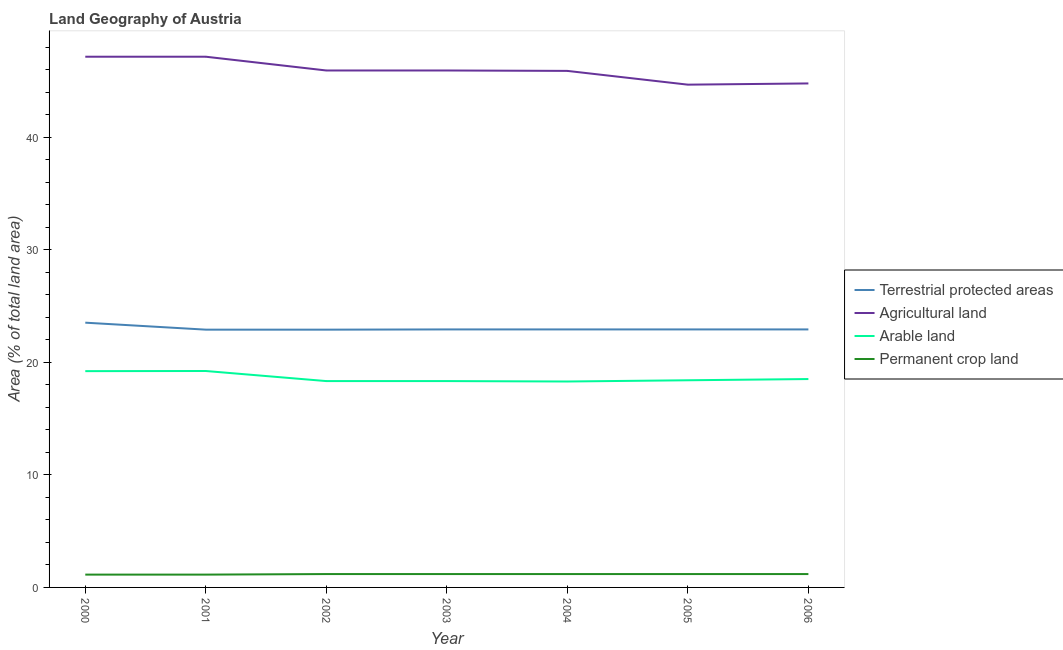Does the line corresponding to percentage of area under arable land intersect with the line corresponding to percentage of land under terrestrial protection?
Offer a very short reply. No. Is the number of lines equal to the number of legend labels?
Your answer should be very brief. Yes. What is the percentage of area under agricultural land in 2001?
Your answer should be very brief. 47.15. Across all years, what is the maximum percentage of area under agricultural land?
Your answer should be compact. 47.15. Across all years, what is the minimum percentage of area under permanent crop land?
Your answer should be very brief. 1.14. In which year was the percentage of area under arable land minimum?
Your response must be concise. 2004. What is the total percentage of area under arable land in the graph?
Keep it short and to the point. 130.33. What is the difference between the percentage of land under terrestrial protection in 2001 and that in 2002?
Your answer should be very brief. -3.987190128995621e-5. What is the difference between the percentage of area under agricultural land in 2006 and the percentage of land under terrestrial protection in 2003?
Ensure brevity in your answer.  21.86. What is the average percentage of area under permanent crop land per year?
Offer a terse response. 1.17. In the year 2002, what is the difference between the percentage of area under agricultural land and percentage of land under terrestrial protection?
Offer a terse response. 23.03. In how many years, is the percentage of land under terrestrial protection greater than 46 %?
Ensure brevity in your answer.  0. What is the ratio of the percentage of area under agricultural land in 2003 to that in 2004?
Ensure brevity in your answer.  1. Is the percentage of area under permanent crop land in 2005 less than that in 2006?
Offer a very short reply. No. What is the difference between the highest and the second highest percentage of area under agricultural land?
Your answer should be very brief. 0. What is the difference between the highest and the lowest percentage of land under terrestrial protection?
Offer a terse response. 0.62. Is the sum of the percentage of area under permanent crop land in 2001 and 2006 greater than the maximum percentage of land under terrestrial protection across all years?
Offer a terse response. No. Is it the case that in every year, the sum of the percentage of area under permanent crop land and percentage of area under arable land is greater than the sum of percentage of land under terrestrial protection and percentage of area under agricultural land?
Your answer should be compact. No. Is it the case that in every year, the sum of the percentage of land under terrestrial protection and percentage of area under agricultural land is greater than the percentage of area under arable land?
Make the answer very short. Yes. Does the percentage of area under permanent crop land monotonically increase over the years?
Your response must be concise. No. Is the percentage of area under permanent crop land strictly greater than the percentage of area under arable land over the years?
Ensure brevity in your answer.  No. Is the percentage of area under permanent crop land strictly less than the percentage of land under terrestrial protection over the years?
Make the answer very short. Yes. Does the graph contain any zero values?
Your answer should be compact. No. Does the graph contain grids?
Give a very brief answer. No. How are the legend labels stacked?
Provide a short and direct response. Vertical. What is the title of the graph?
Your answer should be compact. Land Geography of Austria. Does "Business regulatory environment" appear as one of the legend labels in the graph?
Your response must be concise. No. What is the label or title of the Y-axis?
Your answer should be compact. Area (% of total land area). What is the Area (% of total land area) of Terrestrial protected areas in 2000?
Give a very brief answer. 23.52. What is the Area (% of total land area) in Agricultural land in 2000?
Provide a short and direct response. 47.15. What is the Area (% of total land area) in Arable land in 2000?
Ensure brevity in your answer.  19.22. What is the Area (% of total land area) in Permanent crop land in 2000?
Provide a succinct answer. 1.14. What is the Area (% of total land area) in Terrestrial protected areas in 2001?
Provide a short and direct response. 22.9. What is the Area (% of total land area) in Agricultural land in 2001?
Your answer should be very brief. 47.15. What is the Area (% of total land area) in Arable land in 2001?
Your answer should be compact. 19.23. What is the Area (% of total land area) in Permanent crop land in 2001?
Offer a very short reply. 1.14. What is the Area (% of total land area) in Terrestrial protected areas in 2002?
Your response must be concise. 22.9. What is the Area (% of total land area) in Agricultural land in 2002?
Provide a short and direct response. 45.93. What is the Area (% of total land area) in Arable land in 2002?
Your answer should be compact. 18.33. What is the Area (% of total land area) of Permanent crop land in 2002?
Offer a very short reply. 1.19. What is the Area (% of total land area) in Terrestrial protected areas in 2003?
Your answer should be compact. 22.92. What is the Area (% of total land area) in Agricultural land in 2003?
Provide a short and direct response. 45.93. What is the Area (% of total land area) of Arable land in 2003?
Provide a short and direct response. 18.33. What is the Area (% of total land area) in Permanent crop land in 2003?
Your answer should be very brief. 1.19. What is the Area (% of total land area) in Terrestrial protected areas in 2004?
Provide a succinct answer. 22.92. What is the Area (% of total land area) of Agricultural land in 2004?
Make the answer very short. 45.89. What is the Area (% of total land area) in Arable land in 2004?
Your response must be concise. 18.3. What is the Area (% of total land area) of Permanent crop land in 2004?
Your response must be concise. 1.19. What is the Area (% of total land area) in Terrestrial protected areas in 2005?
Ensure brevity in your answer.  22.92. What is the Area (% of total land area) in Agricultural land in 2005?
Give a very brief answer. 44.67. What is the Area (% of total land area) of Arable land in 2005?
Provide a succinct answer. 18.41. What is the Area (% of total land area) of Permanent crop land in 2005?
Your answer should be compact. 1.19. What is the Area (% of total land area) of Terrestrial protected areas in 2006?
Your answer should be compact. 22.92. What is the Area (% of total land area) of Agricultural land in 2006?
Ensure brevity in your answer.  44.78. What is the Area (% of total land area) of Arable land in 2006?
Offer a very short reply. 18.52. What is the Area (% of total land area) of Permanent crop land in 2006?
Keep it short and to the point. 1.19. Across all years, what is the maximum Area (% of total land area) of Terrestrial protected areas?
Your response must be concise. 23.52. Across all years, what is the maximum Area (% of total land area) of Agricultural land?
Give a very brief answer. 47.15. Across all years, what is the maximum Area (% of total land area) in Arable land?
Offer a terse response. 19.23. Across all years, what is the maximum Area (% of total land area) in Permanent crop land?
Make the answer very short. 1.19. Across all years, what is the minimum Area (% of total land area) of Terrestrial protected areas?
Offer a very short reply. 22.9. Across all years, what is the minimum Area (% of total land area) in Agricultural land?
Give a very brief answer. 44.67. Across all years, what is the minimum Area (% of total land area) of Arable land?
Offer a very short reply. 18.3. Across all years, what is the minimum Area (% of total land area) in Permanent crop land?
Offer a terse response. 1.14. What is the total Area (% of total land area) of Terrestrial protected areas in the graph?
Your answer should be compact. 161.03. What is the total Area (% of total land area) in Agricultural land in the graph?
Give a very brief answer. 321.52. What is the total Area (% of total land area) in Arable land in the graph?
Ensure brevity in your answer.  130.33. What is the total Area (% of total land area) in Permanent crop land in the graph?
Your answer should be compact. 8.21. What is the difference between the Area (% of total land area) of Terrestrial protected areas in 2000 and that in 2001?
Make the answer very short. 0.62. What is the difference between the Area (% of total land area) in Arable land in 2000 and that in 2001?
Make the answer very short. -0.01. What is the difference between the Area (% of total land area) in Terrestrial protected areas in 2000 and that in 2002?
Give a very brief answer. 0.62. What is the difference between the Area (% of total land area) in Agricultural land in 2000 and that in 2002?
Your answer should be compact. 1.22. What is the difference between the Area (% of total land area) of Arable land in 2000 and that in 2002?
Your response must be concise. 0.88. What is the difference between the Area (% of total land area) in Permanent crop land in 2000 and that in 2002?
Your answer should be compact. -0.05. What is the difference between the Area (% of total land area) in Terrestrial protected areas in 2000 and that in 2003?
Your answer should be very brief. 0.6. What is the difference between the Area (% of total land area) in Agricultural land in 2000 and that in 2003?
Provide a succinct answer. 1.22. What is the difference between the Area (% of total land area) in Arable land in 2000 and that in 2003?
Your response must be concise. 0.88. What is the difference between the Area (% of total land area) in Permanent crop land in 2000 and that in 2003?
Make the answer very short. -0.05. What is the difference between the Area (% of total land area) in Terrestrial protected areas in 2000 and that in 2004?
Ensure brevity in your answer.  0.6. What is the difference between the Area (% of total land area) in Agricultural land in 2000 and that in 2004?
Your response must be concise. 1.26. What is the difference between the Area (% of total land area) of Arable land in 2000 and that in 2004?
Your answer should be compact. 0.92. What is the difference between the Area (% of total land area) in Permanent crop land in 2000 and that in 2004?
Provide a succinct answer. -0.05. What is the difference between the Area (% of total land area) in Terrestrial protected areas in 2000 and that in 2005?
Offer a very short reply. 0.6. What is the difference between the Area (% of total land area) of Agricultural land in 2000 and that in 2005?
Make the answer very short. 2.48. What is the difference between the Area (% of total land area) in Arable land in 2000 and that in 2005?
Offer a very short reply. 0.81. What is the difference between the Area (% of total land area) in Permanent crop land in 2000 and that in 2005?
Provide a succinct answer. -0.05. What is the difference between the Area (% of total land area) of Terrestrial protected areas in 2000 and that in 2006?
Make the answer very short. 0.6. What is the difference between the Area (% of total land area) of Agricultural land in 2000 and that in 2006?
Provide a succinct answer. 2.37. What is the difference between the Area (% of total land area) in Arable land in 2000 and that in 2006?
Make the answer very short. 0.7. What is the difference between the Area (% of total land area) of Permanent crop land in 2000 and that in 2006?
Give a very brief answer. -0.05. What is the difference between the Area (% of total land area) in Terrestrial protected areas in 2001 and that in 2002?
Provide a short and direct response. -0. What is the difference between the Area (% of total land area) in Agricultural land in 2001 and that in 2002?
Give a very brief answer. 1.22. What is the difference between the Area (% of total land area) in Arable land in 2001 and that in 2002?
Make the answer very short. 0.9. What is the difference between the Area (% of total land area) of Permanent crop land in 2001 and that in 2002?
Your response must be concise. -0.05. What is the difference between the Area (% of total land area) in Terrestrial protected areas in 2001 and that in 2003?
Keep it short and to the point. -0.02. What is the difference between the Area (% of total land area) of Agricultural land in 2001 and that in 2003?
Offer a very short reply. 1.22. What is the difference between the Area (% of total land area) in Arable land in 2001 and that in 2003?
Provide a short and direct response. 0.9. What is the difference between the Area (% of total land area) in Permanent crop land in 2001 and that in 2003?
Make the answer very short. -0.05. What is the difference between the Area (% of total land area) of Terrestrial protected areas in 2001 and that in 2004?
Your response must be concise. -0.02. What is the difference between the Area (% of total land area) in Agricultural land in 2001 and that in 2004?
Provide a succinct answer. 1.26. What is the difference between the Area (% of total land area) of Arable land in 2001 and that in 2004?
Provide a short and direct response. 0.93. What is the difference between the Area (% of total land area) in Permanent crop land in 2001 and that in 2004?
Your answer should be compact. -0.05. What is the difference between the Area (% of total land area) in Terrestrial protected areas in 2001 and that in 2005?
Give a very brief answer. -0.02. What is the difference between the Area (% of total land area) in Agricultural land in 2001 and that in 2005?
Keep it short and to the point. 2.48. What is the difference between the Area (% of total land area) of Arable land in 2001 and that in 2005?
Give a very brief answer. 0.82. What is the difference between the Area (% of total land area) of Permanent crop land in 2001 and that in 2005?
Your answer should be very brief. -0.05. What is the difference between the Area (% of total land area) of Terrestrial protected areas in 2001 and that in 2006?
Your answer should be very brief. -0.02. What is the difference between the Area (% of total land area) in Agricultural land in 2001 and that in 2006?
Provide a short and direct response. 2.37. What is the difference between the Area (% of total land area) in Arable land in 2001 and that in 2006?
Your response must be concise. 0.71. What is the difference between the Area (% of total land area) in Permanent crop land in 2001 and that in 2006?
Provide a short and direct response. -0.05. What is the difference between the Area (% of total land area) of Terrestrial protected areas in 2002 and that in 2003?
Keep it short and to the point. -0.02. What is the difference between the Area (% of total land area) in Permanent crop land in 2002 and that in 2003?
Your answer should be very brief. 0. What is the difference between the Area (% of total land area) in Terrestrial protected areas in 2002 and that in 2004?
Provide a short and direct response. -0.02. What is the difference between the Area (% of total land area) in Agricultural land in 2002 and that in 2004?
Provide a short and direct response. 0.04. What is the difference between the Area (% of total land area) of Arable land in 2002 and that in 2004?
Offer a terse response. 0.04. What is the difference between the Area (% of total land area) of Permanent crop land in 2002 and that in 2004?
Keep it short and to the point. 0. What is the difference between the Area (% of total land area) of Terrestrial protected areas in 2002 and that in 2005?
Provide a succinct answer. -0.02. What is the difference between the Area (% of total land area) of Agricultural land in 2002 and that in 2005?
Ensure brevity in your answer.  1.26. What is the difference between the Area (% of total land area) in Arable land in 2002 and that in 2005?
Make the answer very short. -0.07. What is the difference between the Area (% of total land area) of Terrestrial protected areas in 2002 and that in 2006?
Offer a very short reply. -0.02. What is the difference between the Area (% of total land area) of Agricultural land in 2002 and that in 2006?
Ensure brevity in your answer.  1.15. What is the difference between the Area (% of total land area) of Arable land in 2002 and that in 2006?
Your answer should be compact. -0.18. What is the difference between the Area (% of total land area) in Permanent crop land in 2002 and that in 2006?
Make the answer very short. 0. What is the difference between the Area (% of total land area) of Terrestrial protected areas in 2003 and that in 2004?
Make the answer very short. 0. What is the difference between the Area (% of total land area) in Agricultural land in 2003 and that in 2004?
Your response must be concise. 0.04. What is the difference between the Area (% of total land area) in Arable land in 2003 and that in 2004?
Give a very brief answer. 0.04. What is the difference between the Area (% of total land area) of Agricultural land in 2003 and that in 2005?
Your response must be concise. 1.26. What is the difference between the Area (% of total land area) in Arable land in 2003 and that in 2005?
Give a very brief answer. -0.07. What is the difference between the Area (% of total land area) in Terrestrial protected areas in 2003 and that in 2006?
Keep it short and to the point. 0. What is the difference between the Area (% of total land area) of Agricultural land in 2003 and that in 2006?
Ensure brevity in your answer.  1.15. What is the difference between the Area (% of total land area) in Arable land in 2003 and that in 2006?
Your answer should be very brief. -0.18. What is the difference between the Area (% of total land area) in Permanent crop land in 2003 and that in 2006?
Your response must be concise. 0. What is the difference between the Area (% of total land area) in Agricultural land in 2004 and that in 2005?
Keep it short and to the point. 1.22. What is the difference between the Area (% of total land area) of Arable land in 2004 and that in 2005?
Offer a very short reply. -0.11. What is the difference between the Area (% of total land area) in Agricultural land in 2004 and that in 2006?
Your answer should be compact. 1.11. What is the difference between the Area (% of total land area) of Arable land in 2004 and that in 2006?
Offer a terse response. -0.22. What is the difference between the Area (% of total land area) in Permanent crop land in 2004 and that in 2006?
Give a very brief answer. 0. What is the difference between the Area (% of total land area) of Terrestrial protected areas in 2005 and that in 2006?
Your answer should be very brief. 0. What is the difference between the Area (% of total land area) in Agricultural land in 2005 and that in 2006?
Keep it short and to the point. -0.11. What is the difference between the Area (% of total land area) of Arable land in 2005 and that in 2006?
Provide a short and direct response. -0.11. What is the difference between the Area (% of total land area) in Terrestrial protected areas in 2000 and the Area (% of total land area) in Agricultural land in 2001?
Your answer should be compact. -23.63. What is the difference between the Area (% of total land area) of Terrestrial protected areas in 2000 and the Area (% of total land area) of Arable land in 2001?
Ensure brevity in your answer.  4.29. What is the difference between the Area (% of total land area) in Terrestrial protected areas in 2000 and the Area (% of total land area) in Permanent crop land in 2001?
Provide a short and direct response. 22.39. What is the difference between the Area (% of total land area) in Agricultural land in 2000 and the Area (% of total land area) in Arable land in 2001?
Give a very brief answer. 27.92. What is the difference between the Area (% of total land area) in Agricultural land in 2000 and the Area (% of total land area) in Permanent crop land in 2001?
Offer a terse response. 46.02. What is the difference between the Area (% of total land area) of Arable land in 2000 and the Area (% of total land area) of Permanent crop land in 2001?
Ensure brevity in your answer.  18.08. What is the difference between the Area (% of total land area) of Terrestrial protected areas in 2000 and the Area (% of total land area) of Agricultural land in 2002?
Keep it short and to the point. -22.41. What is the difference between the Area (% of total land area) of Terrestrial protected areas in 2000 and the Area (% of total land area) of Arable land in 2002?
Make the answer very short. 5.19. What is the difference between the Area (% of total land area) in Terrestrial protected areas in 2000 and the Area (% of total land area) in Permanent crop land in 2002?
Ensure brevity in your answer.  22.34. What is the difference between the Area (% of total land area) of Agricultural land in 2000 and the Area (% of total land area) of Arable land in 2002?
Your answer should be compact. 28.82. What is the difference between the Area (% of total land area) in Agricultural land in 2000 and the Area (% of total land area) in Permanent crop land in 2002?
Offer a very short reply. 45.97. What is the difference between the Area (% of total land area) in Arable land in 2000 and the Area (% of total land area) in Permanent crop land in 2002?
Provide a succinct answer. 18.03. What is the difference between the Area (% of total land area) in Terrestrial protected areas in 2000 and the Area (% of total land area) in Agricultural land in 2003?
Your answer should be compact. -22.41. What is the difference between the Area (% of total land area) of Terrestrial protected areas in 2000 and the Area (% of total land area) of Arable land in 2003?
Your answer should be compact. 5.19. What is the difference between the Area (% of total land area) in Terrestrial protected areas in 2000 and the Area (% of total land area) in Permanent crop land in 2003?
Your response must be concise. 22.34. What is the difference between the Area (% of total land area) in Agricultural land in 2000 and the Area (% of total land area) in Arable land in 2003?
Ensure brevity in your answer.  28.82. What is the difference between the Area (% of total land area) in Agricultural land in 2000 and the Area (% of total land area) in Permanent crop land in 2003?
Provide a short and direct response. 45.97. What is the difference between the Area (% of total land area) in Arable land in 2000 and the Area (% of total land area) in Permanent crop land in 2003?
Give a very brief answer. 18.03. What is the difference between the Area (% of total land area) in Terrestrial protected areas in 2000 and the Area (% of total land area) in Agricultural land in 2004?
Your answer should be very brief. -22.37. What is the difference between the Area (% of total land area) in Terrestrial protected areas in 2000 and the Area (% of total land area) in Arable land in 2004?
Give a very brief answer. 5.23. What is the difference between the Area (% of total land area) in Terrestrial protected areas in 2000 and the Area (% of total land area) in Permanent crop land in 2004?
Offer a terse response. 22.34. What is the difference between the Area (% of total land area) of Agricultural land in 2000 and the Area (% of total land area) of Arable land in 2004?
Provide a succinct answer. 28.86. What is the difference between the Area (% of total land area) in Agricultural land in 2000 and the Area (% of total land area) in Permanent crop land in 2004?
Offer a terse response. 45.97. What is the difference between the Area (% of total land area) of Arable land in 2000 and the Area (% of total land area) of Permanent crop land in 2004?
Keep it short and to the point. 18.03. What is the difference between the Area (% of total land area) of Terrestrial protected areas in 2000 and the Area (% of total land area) of Agricultural land in 2005?
Give a very brief answer. -21.15. What is the difference between the Area (% of total land area) of Terrestrial protected areas in 2000 and the Area (% of total land area) of Arable land in 2005?
Ensure brevity in your answer.  5.12. What is the difference between the Area (% of total land area) of Terrestrial protected areas in 2000 and the Area (% of total land area) of Permanent crop land in 2005?
Offer a terse response. 22.34. What is the difference between the Area (% of total land area) of Agricultural land in 2000 and the Area (% of total land area) of Arable land in 2005?
Ensure brevity in your answer.  28.75. What is the difference between the Area (% of total land area) in Agricultural land in 2000 and the Area (% of total land area) in Permanent crop land in 2005?
Your answer should be compact. 45.97. What is the difference between the Area (% of total land area) in Arable land in 2000 and the Area (% of total land area) in Permanent crop land in 2005?
Provide a succinct answer. 18.03. What is the difference between the Area (% of total land area) in Terrestrial protected areas in 2000 and the Area (% of total land area) in Agricultural land in 2006?
Make the answer very short. -21.26. What is the difference between the Area (% of total land area) of Terrestrial protected areas in 2000 and the Area (% of total land area) of Arable land in 2006?
Offer a very short reply. 5.01. What is the difference between the Area (% of total land area) of Terrestrial protected areas in 2000 and the Area (% of total land area) of Permanent crop land in 2006?
Provide a succinct answer. 22.34. What is the difference between the Area (% of total land area) of Agricultural land in 2000 and the Area (% of total land area) of Arable land in 2006?
Provide a short and direct response. 28.64. What is the difference between the Area (% of total land area) in Agricultural land in 2000 and the Area (% of total land area) in Permanent crop land in 2006?
Give a very brief answer. 45.97. What is the difference between the Area (% of total land area) of Arable land in 2000 and the Area (% of total land area) of Permanent crop land in 2006?
Your response must be concise. 18.03. What is the difference between the Area (% of total land area) of Terrestrial protected areas in 2001 and the Area (% of total land area) of Agricultural land in 2002?
Your answer should be compact. -23.03. What is the difference between the Area (% of total land area) of Terrestrial protected areas in 2001 and the Area (% of total land area) of Arable land in 2002?
Make the answer very short. 4.57. What is the difference between the Area (% of total land area) in Terrestrial protected areas in 2001 and the Area (% of total land area) in Permanent crop land in 2002?
Provide a short and direct response. 21.72. What is the difference between the Area (% of total land area) in Agricultural land in 2001 and the Area (% of total land area) in Arable land in 2002?
Make the answer very short. 28.82. What is the difference between the Area (% of total land area) of Agricultural land in 2001 and the Area (% of total land area) of Permanent crop land in 2002?
Your response must be concise. 45.97. What is the difference between the Area (% of total land area) in Arable land in 2001 and the Area (% of total land area) in Permanent crop land in 2002?
Provide a short and direct response. 18.04. What is the difference between the Area (% of total land area) in Terrestrial protected areas in 2001 and the Area (% of total land area) in Agricultural land in 2003?
Ensure brevity in your answer.  -23.03. What is the difference between the Area (% of total land area) in Terrestrial protected areas in 2001 and the Area (% of total land area) in Arable land in 2003?
Your answer should be very brief. 4.57. What is the difference between the Area (% of total land area) of Terrestrial protected areas in 2001 and the Area (% of total land area) of Permanent crop land in 2003?
Your answer should be very brief. 21.72. What is the difference between the Area (% of total land area) in Agricultural land in 2001 and the Area (% of total land area) in Arable land in 2003?
Give a very brief answer. 28.82. What is the difference between the Area (% of total land area) of Agricultural land in 2001 and the Area (% of total land area) of Permanent crop land in 2003?
Your response must be concise. 45.97. What is the difference between the Area (% of total land area) in Arable land in 2001 and the Area (% of total land area) in Permanent crop land in 2003?
Offer a terse response. 18.04. What is the difference between the Area (% of total land area) in Terrestrial protected areas in 2001 and the Area (% of total land area) in Agricultural land in 2004?
Keep it short and to the point. -22.99. What is the difference between the Area (% of total land area) in Terrestrial protected areas in 2001 and the Area (% of total land area) in Arable land in 2004?
Make the answer very short. 4.61. What is the difference between the Area (% of total land area) in Terrestrial protected areas in 2001 and the Area (% of total land area) in Permanent crop land in 2004?
Provide a succinct answer. 21.72. What is the difference between the Area (% of total land area) of Agricultural land in 2001 and the Area (% of total land area) of Arable land in 2004?
Your answer should be very brief. 28.86. What is the difference between the Area (% of total land area) in Agricultural land in 2001 and the Area (% of total land area) in Permanent crop land in 2004?
Offer a terse response. 45.97. What is the difference between the Area (% of total land area) in Arable land in 2001 and the Area (% of total land area) in Permanent crop land in 2004?
Your answer should be very brief. 18.04. What is the difference between the Area (% of total land area) of Terrestrial protected areas in 2001 and the Area (% of total land area) of Agricultural land in 2005?
Your answer should be compact. -21.77. What is the difference between the Area (% of total land area) of Terrestrial protected areas in 2001 and the Area (% of total land area) of Arable land in 2005?
Offer a terse response. 4.5. What is the difference between the Area (% of total land area) in Terrestrial protected areas in 2001 and the Area (% of total land area) in Permanent crop land in 2005?
Ensure brevity in your answer.  21.72. What is the difference between the Area (% of total land area) of Agricultural land in 2001 and the Area (% of total land area) of Arable land in 2005?
Your answer should be very brief. 28.75. What is the difference between the Area (% of total land area) of Agricultural land in 2001 and the Area (% of total land area) of Permanent crop land in 2005?
Offer a terse response. 45.97. What is the difference between the Area (% of total land area) of Arable land in 2001 and the Area (% of total land area) of Permanent crop land in 2005?
Provide a succinct answer. 18.04. What is the difference between the Area (% of total land area) in Terrestrial protected areas in 2001 and the Area (% of total land area) in Agricultural land in 2006?
Keep it short and to the point. -21.88. What is the difference between the Area (% of total land area) of Terrestrial protected areas in 2001 and the Area (% of total land area) of Arable land in 2006?
Offer a very short reply. 4.39. What is the difference between the Area (% of total land area) of Terrestrial protected areas in 2001 and the Area (% of total land area) of Permanent crop land in 2006?
Make the answer very short. 21.72. What is the difference between the Area (% of total land area) of Agricultural land in 2001 and the Area (% of total land area) of Arable land in 2006?
Ensure brevity in your answer.  28.64. What is the difference between the Area (% of total land area) of Agricultural land in 2001 and the Area (% of total land area) of Permanent crop land in 2006?
Make the answer very short. 45.97. What is the difference between the Area (% of total land area) of Arable land in 2001 and the Area (% of total land area) of Permanent crop land in 2006?
Your answer should be compact. 18.04. What is the difference between the Area (% of total land area) in Terrestrial protected areas in 2002 and the Area (% of total land area) in Agricultural land in 2003?
Keep it short and to the point. -23.03. What is the difference between the Area (% of total land area) in Terrestrial protected areas in 2002 and the Area (% of total land area) in Arable land in 2003?
Keep it short and to the point. 4.57. What is the difference between the Area (% of total land area) in Terrestrial protected areas in 2002 and the Area (% of total land area) in Permanent crop land in 2003?
Provide a succinct answer. 21.72. What is the difference between the Area (% of total land area) of Agricultural land in 2002 and the Area (% of total land area) of Arable land in 2003?
Make the answer very short. 27.6. What is the difference between the Area (% of total land area) of Agricultural land in 2002 and the Area (% of total land area) of Permanent crop land in 2003?
Give a very brief answer. 44.74. What is the difference between the Area (% of total land area) of Arable land in 2002 and the Area (% of total land area) of Permanent crop land in 2003?
Make the answer very short. 17.15. What is the difference between the Area (% of total land area) of Terrestrial protected areas in 2002 and the Area (% of total land area) of Agricultural land in 2004?
Provide a succinct answer. -22.99. What is the difference between the Area (% of total land area) of Terrestrial protected areas in 2002 and the Area (% of total land area) of Arable land in 2004?
Your answer should be very brief. 4.61. What is the difference between the Area (% of total land area) in Terrestrial protected areas in 2002 and the Area (% of total land area) in Permanent crop land in 2004?
Provide a succinct answer. 21.72. What is the difference between the Area (% of total land area) of Agricultural land in 2002 and the Area (% of total land area) of Arable land in 2004?
Your answer should be compact. 27.63. What is the difference between the Area (% of total land area) in Agricultural land in 2002 and the Area (% of total land area) in Permanent crop land in 2004?
Offer a terse response. 44.74. What is the difference between the Area (% of total land area) in Arable land in 2002 and the Area (% of total land area) in Permanent crop land in 2004?
Offer a terse response. 17.15. What is the difference between the Area (% of total land area) in Terrestrial protected areas in 2002 and the Area (% of total land area) in Agricultural land in 2005?
Give a very brief answer. -21.77. What is the difference between the Area (% of total land area) of Terrestrial protected areas in 2002 and the Area (% of total land area) of Arable land in 2005?
Your answer should be compact. 4.5. What is the difference between the Area (% of total land area) in Terrestrial protected areas in 2002 and the Area (% of total land area) in Permanent crop land in 2005?
Offer a terse response. 21.72. What is the difference between the Area (% of total land area) in Agricultural land in 2002 and the Area (% of total land area) in Arable land in 2005?
Offer a terse response. 27.52. What is the difference between the Area (% of total land area) in Agricultural land in 2002 and the Area (% of total land area) in Permanent crop land in 2005?
Your answer should be very brief. 44.74. What is the difference between the Area (% of total land area) of Arable land in 2002 and the Area (% of total land area) of Permanent crop land in 2005?
Your answer should be very brief. 17.15. What is the difference between the Area (% of total land area) in Terrestrial protected areas in 2002 and the Area (% of total land area) in Agricultural land in 2006?
Offer a very short reply. -21.88. What is the difference between the Area (% of total land area) of Terrestrial protected areas in 2002 and the Area (% of total land area) of Arable land in 2006?
Your response must be concise. 4.39. What is the difference between the Area (% of total land area) of Terrestrial protected areas in 2002 and the Area (% of total land area) of Permanent crop land in 2006?
Your answer should be very brief. 21.72. What is the difference between the Area (% of total land area) in Agricultural land in 2002 and the Area (% of total land area) in Arable land in 2006?
Provide a succinct answer. 27.42. What is the difference between the Area (% of total land area) in Agricultural land in 2002 and the Area (% of total land area) in Permanent crop land in 2006?
Your answer should be very brief. 44.74. What is the difference between the Area (% of total land area) in Arable land in 2002 and the Area (% of total land area) in Permanent crop land in 2006?
Ensure brevity in your answer.  17.15. What is the difference between the Area (% of total land area) of Terrestrial protected areas in 2003 and the Area (% of total land area) of Agricultural land in 2004?
Ensure brevity in your answer.  -22.97. What is the difference between the Area (% of total land area) in Terrestrial protected areas in 2003 and the Area (% of total land area) in Arable land in 2004?
Make the answer very short. 4.63. What is the difference between the Area (% of total land area) in Terrestrial protected areas in 2003 and the Area (% of total land area) in Permanent crop land in 2004?
Keep it short and to the point. 21.74. What is the difference between the Area (% of total land area) of Agricultural land in 2003 and the Area (% of total land area) of Arable land in 2004?
Offer a very short reply. 27.63. What is the difference between the Area (% of total land area) in Agricultural land in 2003 and the Area (% of total land area) in Permanent crop land in 2004?
Ensure brevity in your answer.  44.74. What is the difference between the Area (% of total land area) in Arable land in 2003 and the Area (% of total land area) in Permanent crop land in 2004?
Your response must be concise. 17.15. What is the difference between the Area (% of total land area) in Terrestrial protected areas in 2003 and the Area (% of total land area) in Agricultural land in 2005?
Offer a very short reply. -21.75. What is the difference between the Area (% of total land area) of Terrestrial protected areas in 2003 and the Area (% of total land area) of Arable land in 2005?
Offer a terse response. 4.52. What is the difference between the Area (% of total land area) in Terrestrial protected areas in 2003 and the Area (% of total land area) in Permanent crop land in 2005?
Provide a short and direct response. 21.74. What is the difference between the Area (% of total land area) of Agricultural land in 2003 and the Area (% of total land area) of Arable land in 2005?
Offer a terse response. 27.52. What is the difference between the Area (% of total land area) in Agricultural land in 2003 and the Area (% of total land area) in Permanent crop land in 2005?
Offer a terse response. 44.74. What is the difference between the Area (% of total land area) of Arable land in 2003 and the Area (% of total land area) of Permanent crop land in 2005?
Your answer should be very brief. 17.15. What is the difference between the Area (% of total land area) of Terrestrial protected areas in 2003 and the Area (% of total land area) of Agricultural land in 2006?
Offer a terse response. -21.86. What is the difference between the Area (% of total land area) in Terrestrial protected areas in 2003 and the Area (% of total land area) in Arable land in 2006?
Give a very brief answer. 4.41. What is the difference between the Area (% of total land area) of Terrestrial protected areas in 2003 and the Area (% of total land area) of Permanent crop land in 2006?
Keep it short and to the point. 21.74. What is the difference between the Area (% of total land area) of Agricultural land in 2003 and the Area (% of total land area) of Arable land in 2006?
Your answer should be compact. 27.42. What is the difference between the Area (% of total land area) of Agricultural land in 2003 and the Area (% of total land area) of Permanent crop land in 2006?
Your answer should be very brief. 44.74. What is the difference between the Area (% of total land area) of Arable land in 2003 and the Area (% of total land area) of Permanent crop land in 2006?
Make the answer very short. 17.15. What is the difference between the Area (% of total land area) in Terrestrial protected areas in 2004 and the Area (% of total land area) in Agricultural land in 2005?
Give a very brief answer. -21.75. What is the difference between the Area (% of total land area) in Terrestrial protected areas in 2004 and the Area (% of total land area) in Arable land in 2005?
Offer a terse response. 4.52. What is the difference between the Area (% of total land area) of Terrestrial protected areas in 2004 and the Area (% of total land area) of Permanent crop land in 2005?
Your answer should be compact. 21.74. What is the difference between the Area (% of total land area) of Agricultural land in 2004 and the Area (% of total land area) of Arable land in 2005?
Your response must be concise. 27.49. What is the difference between the Area (% of total land area) of Agricultural land in 2004 and the Area (% of total land area) of Permanent crop land in 2005?
Provide a short and direct response. 44.71. What is the difference between the Area (% of total land area) of Arable land in 2004 and the Area (% of total land area) of Permanent crop land in 2005?
Your answer should be very brief. 17.11. What is the difference between the Area (% of total land area) in Terrestrial protected areas in 2004 and the Area (% of total land area) in Agricultural land in 2006?
Keep it short and to the point. -21.86. What is the difference between the Area (% of total land area) in Terrestrial protected areas in 2004 and the Area (% of total land area) in Arable land in 2006?
Ensure brevity in your answer.  4.41. What is the difference between the Area (% of total land area) of Terrestrial protected areas in 2004 and the Area (% of total land area) of Permanent crop land in 2006?
Your answer should be compact. 21.74. What is the difference between the Area (% of total land area) in Agricultural land in 2004 and the Area (% of total land area) in Arable land in 2006?
Your answer should be compact. 27.38. What is the difference between the Area (% of total land area) of Agricultural land in 2004 and the Area (% of total land area) of Permanent crop land in 2006?
Ensure brevity in your answer.  44.71. What is the difference between the Area (% of total land area) in Arable land in 2004 and the Area (% of total land area) in Permanent crop land in 2006?
Provide a short and direct response. 17.11. What is the difference between the Area (% of total land area) of Terrestrial protected areas in 2005 and the Area (% of total land area) of Agricultural land in 2006?
Ensure brevity in your answer.  -21.86. What is the difference between the Area (% of total land area) in Terrestrial protected areas in 2005 and the Area (% of total land area) in Arable land in 2006?
Make the answer very short. 4.41. What is the difference between the Area (% of total land area) in Terrestrial protected areas in 2005 and the Area (% of total land area) in Permanent crop land in 2006?
Provide a short and direct response. 21.74. What is the difference between the Area (% of total land area) of Agricultural land in 2005 and the Area (% of total land area) of Arable land in 2006?
Your answer should be very brief. 26.16. What is the difference between the Area (% of total land area) in Agricultural land in 2005 and the Area (% of total land area) in Permanent crop land in 2006?
Make the answer very short. 43.49. What is the difference between the Area (% of total land area) of Arable land in 2005 and the Area (% of total land area) of Permanent crop land in 2006?
Give a very brief answer. 17.22. What is the average Area (% of total land area) in Terrestrial protected areas per year?
Give a very brief answer. 23. What is the average Area (% of total land area) of Agricultural land per year?
Provide a succinct answer. 45.93. What is the average Area (% of total land area) in Arable land per year?
Keep it short and to the point. 18.62. What is the average Area (% of total land area) of Permanent crop land per year?
Ensure brevity in your answer.  1.17. In the year 2000, what is the difference between the Area (% of total land area) in Terrestrial protected areas and Area (% of total land area) in Agricultural land?
Your answer should be compact. -23.63. In the year 2000, what is the difference between the Area (% of total land area) in Terrestrial protected areas and Area (% of total land area) in Arable land?
Provide a succinct answer. 4.31. In the year 2000, what is the difference between the Area (% of total land area) of Terrestrial protected areas and Area (% of total land area) of Permanent crop land?
Offer a very short reply. 22.39. In the year 2000, what is the difference between the Area (% of total land area) of Agricultural land and Area (% of total land area) of Arable land?
Give a very brief answer. 27.94. In the year 2000, what is the difference between the Area (% of total land area) in Agricultural land and Area (% of total land area) in Permanent crop land?
Your response must be concise. 46.02. In the year 2000, what is the difference between the Area (% of total land area) in Arable land and Area (% of total land area) in Permanent crop land?
Make the answer very short. 18.08. In the year 2001, what is the difference between the Area (% of total land area) in Terrestrial protected areas and Area (% of total land area) in Agricultural land?
Your answer should be very brief. -24.25. In the year 2001, what is the difference between the Area (% of total land area) of Terrestrial protected areas and Area (% of total land area) of Arable land?
Provide a short and direct response. 3.67. In the year 2001, what is the difference between the Area (% of total land area) in Terrestrial protected areas and Area (% of total land area) in Permanent crop land?
Your answer should be compact. 21.77. In the year 2001, what is the difference between the Area (% of total land area) of Agricultural land and Area (% of total land area) of Arable land?
Provide a succinct answer. 27.92. In the year 2001, what is the difference between the Area (% of total land area) of Agricultural land and Area (% of total land area) of Permanent crop land?
Provide a succinct answer. 46.02. In the year 2001, what is the difference between the Area (% of total land area) of Arable land and Area (% of total land area) of Permanent crop land?
Give a very brief answer. 18.09. In the year 2002, what is the difference between the Area (% of total land area) of Terrestrial protected areas and Area (% of total land area) of Agricultural land?
Keep it short and to the point. -23.03. In the year 2002, what is the difference between the Area (% of total land area) of Terrestrial protected areas and Area (% of total land area) of Arable land?
Ensure brevity in your answer.  4.57. In the year 2002, what is the difference between the Area (% of total land area) of Terrestrial protected areas and Area (% of total land area) of Permanent crop land?
Offer a terse response. 21.72. In the year 2002, what is the difference between the Area (% of total land area) in Agricultural land and Area (% of total land area) in Arable land?
Give a very brief answer. 27.6. In the year 2002, what is the difference between the Area (% of total land area) of Agricultural land and Area (% of total land area) of Permanent crop land?
Ensure brevity in your answer.  44.74. In the year 2002, what is the difference between the Area (% of total land area) in Arable land and Area (% of total land area) in Permanent crop land?
Offer a very short reply. 17.15. In the year 2003, what is the difference between the Area (% of total land area) of Terrestrial protected areas and Area (% of total land area) of Agricultural land?
Give a very brief answer. -23.01. In the year 2003, what is the difference between the Area (% of total land area) in Terrestrial protected areas and Area (% of total land area) in Arable land?
Offer a terse response. 4.59. In the year 2003, what is the difference between the Area (% of total land area) of Terrestrial protected areas and Area (% of total land area) of Permanent crop land?
Provide a short and direct response. 21.74. In the year 2003, what is the difference between the Area (% of total land area) of Agricultural land and Area (% of total land area) of Arable land?
Your answer should be very brief. 27.6. In the year 2003, what is the difference between the Area (% of total land area) of Agricultural land and Area (% of total land area) of Permanent crop land?
Offer a terse response. 44.74. In the year 2003, what is the difference between the Area (% of total land area) in Arable land and Area (% of total land area) in Permanent crop land?
Your answer should be compact. 17.15. In the year 2004, what is the difference between the Area (% of total land area) of Terrestrial protected areas and Area (% of total land area) of Agricultural land?
Provide a succinct answer. -22.97. In the year 2004, what is the difference between the Area (% of total land area) in Terrestrial protected areas and Area (% of total land area) in Arable land?
Make the answer very short. 4.63. In the year 2004, what is the difference between the Area (% of total land area) of Terrestrial protected areas and Area (% of total land area) of Permanent crop land?
Your answer should be very brief. 21.74. In the year 2004, what is the difference between the Area (% of total land area) of Agricultural land and Area (% of total land area) of Arable land?
Keep it short and to the point. 27.6. In the year 2004, what is the difference between the Area (% of total land area) of Agricultural land and Area (% of total land area) of Permanent crop land?
Provide a short and direct response. 44.71. In the year 2004, what is the difference between the Area (% of total land area) in Arable land and Area (% of total land area) in Permanent crop land?
Provide a short and direct response. 17.11. In the year 2005, what is the difference between the Area (% of total land area) of Terrestrial protected areas and Area (% of total land area) of Agricultural land?
Your answer should be very brief. -21.75. In the year 2005, what is the difference between the Area (% of total land area) of Terrestrial protected areas and Area (% of total land area) of Arable land?
Provide a short and direct response. 4.52. In the year 2005, what is the difference between the Area (% of total land area) of Terrestrial protected areas and Area (% of total land area) of Permanent crop land?
Your answer should be compact. 21.74. In the year 2005, what is the difference between the Area (% of total land area) of Agricultural land and Area (% of total land area) of Arable land?
Provide a succinct answer. 26.27. In the year 2005, what is the difference between the Area (% of total land area) of Agricultural land and Area (% of total land area) of Permanent crop land?
Your answer should be very brief. 43.49. In the year 2005, what is the difference between the Area (% of total land area) of Arable land and Area (% of total land area) of Permanent crop land?
Give a very brief answer. 17.22. In the year 2006, what is the difference between the Area (% of total land area) of Terrestrial protected areas and Area (% of total land area) of Agricultural land?
Ensure brevity in your answer.  -21.86. In the year 2006, what is the difference between the Area (% of total land area) in Terrestrial protected areas and Area (% of total land area) in Arable land?
Provide a short and direct response. 4.41. In the year 2006, what is the difference between the Area (% of total land area) in Terrestrial protected areas and Area (% of total land area) in Permanent crop land?
Keep it short and to the point. 21.74. In the year 2006, what is the difference between the Area (% of total land area) in Agricultural land and Area (% of total land area) in Arable land?
Offer a terse response. 26.27. In the year 2006, what is the difference between the Area (% of total land area) in Agricultural land and Area (% of total land area) in Permanent crop land?
Give a very brief answer. 43.59. In the year 2006, what is the difference between the Area (% of total land area) of Arable land and Area (% of total land area) of Permanent crop land?
Provide a short and direct response. 17.33. What is the ratio of the Area (% of total land area) in Terrestrial protected areas in 2000 to that in 2001?
Offer a terse response. 1.03. What is the ratio of the Area (% of total land area) of Arable land in 2000 to that in 2001?
Offer a terse response. 1. What is the ratio of the Area (% of total land area) of Permanent crop land in 2000 to that in 2001?
Keep it short and to the point. 1. What is the ratio of the Area (% of total land area) in Terrestrial protected areas in 2000 to that in 2002?
Make the answer very short. 1.03. What is the ratio of the Area (% of total land area) in Agricultural land in 2000 to that in 2002?
Keep it short and to the point. 1.03. What is the ratio of the Area (% of total land area) of Arable land in 2000 to that in 2002?
Provide a short and direct response. 1.05. What is the ratio of the Area (% of total land area) in Permanent crop land in 2000 to that in 2002?
Provide a succinct answer. 0.96. What is the ratio of the Area (% of total land area) in Terrestrial protected areas in 2000 to that in 2003?
Your answer should be very brief. 1.03. What is the ratio of the Area (% of total land area) of Agricultural land in 2000 to that in 2003?
Offer a very short reply. 1.03. What is the ratio of the Area (% of total land area) of Arable land in 2000 to that in 2003?
Ensure brevity in your answer.  1.05. What is the ratio of the Area (% of total land area) in Permanent crop land in 2000 to that in 2003?
Offer a very short reply. 0.96. What is the ratio of the Area (% of total land area) of Terrestrial protected areas in 2000 to that in 2004?
Provide a short and direct response. 1.03. What is the ratio of the Area (% of total land area) in Agricultural land in 2000 to that in 2004?
Give a very brief answer. 1.03. What is the ratio of the Area (% of total land area) in Arable land in 2000 to that in 2004?
Your response must be concise. 1.05. What is the ratio of the Area (% of total land area) of Permanent crop land in 2000 to that in 2004?
Provide a succinct answer. 0.96. What is the ratio of the Area (% of total land area) in Terrestrial protected areas in 2000 to that in 2005?
Offer a very short reply. 1.03. What is the ratio of the Area (% of total land area) in Agricultural land in 2000 to that in 2005?
Give a very brief answer. 1.06. What is the ratio of the Area (% of total land area) of Arable land in 2000 to that in 2005?
Offer a terse response. 1.04. What is the ratio of the Area (% of total land area) in Permanent crop land in 2000 to that in 2005?
Offer a terse response. 0.96. What is the ratio of the Area (% of total land area) of Terrestrial protected areas in 2000 to that in 2006?
Provide a short and direct response. 1.03. What is the ratio of the Area (% of total land area) of Agricultural land in 2000 to that in 2006?
Make the answer very short. 1.05. What is the ratio of the Area (% of total land area) in Arable land in 2000 to that in 2006?
Make the answer very short. 1.04. What is the ratio of the Area (% of total land area) of Permanent crop land in 2000 to that in 2006?
Ensure brevity in your answer.  0.96. What is the ratio of the Area (% of total land area) in Terrestrial protected areas in 2001 to that in 2002?
Provide a succinct answer. 1. What is the ratio of the Area (% of total land area) of Agricultural land in 2001 to that in 2002?
Make the answer very short. 1.03. What is the ratio of the Area (% of total land area) of Arable land in 2001 to that in 2002?
Provide a succinct answer. 1.05. What is the ratio of the Area (% of total land area) in Permanent crop land in 2001 to that in 2002?
Your answer should be compact. 0.96. What is the ratio of the Area (% of total land area) of Agricultural land in 2001 to that in 2003?
Offer a very short reply. 1.03. What is the ratio of the Area (% of total land area) of Arable land in 2001 to that in 2003?
Give a very brief answer. 1.05. What is the ratio of the Area (% of total land area) of Permanent crop land in 2001 to that in 2003?
Keep it short and to the point. 0.96. What is the ratio of the Area (% of total land area) of Terrestrial protected areas in 2001 to that in 2004?
Make the answer very short. 1. What is the ratio of the Area (% of total land area) of Agricultural land in 2001 to that in 2004?
Your answer should be very brief. 1.03. What is the ratio of the Area (% of total land area) in Arable land in 2001 to that in 2004?
Give a very brief answer. 1.05. What is the ratio of the Area (% of total land area) of Permanent crop land in 2001 to that in 2004?
Offer a very short reply. 0.96. What is the ratio of the Area (% of total land area) of Terrestrial protected areas in 2001 to that in 2005?
Your answer should be compact. 1. What is the ratio of the Area (% of total land area) in Agricultural land in 2001 to that in 2005?
Keep it short and to the point. 1.06. What is the ratio of the Area (% of total land area) of Arable land in 2001 to that in 2005?
Your answer should be very brief. 1.04. What is the ratio of the Area (% of total land area) in Permanent crop land in 2001 to that in 2005?
Ensure brevity in your answer.  0.96. What is the ratio of the Area (% of total land area) of Agricultural land in 2001 to that in 2006?
Your answer should be compact. 1.05. What is the ratio of the Area (% of total land area) in Arable land in 2001 to that in 2006?
Offer a very short reply. 1.04. What is the ratio of the Area (% of total land area) in Permanent crop land in 2001 to that in 2006?
Make the answer very short. 0.96. What is the ratio of the Area (% of total land area) in Arable land in 2002 to that in 2003?
Give a very brief answer. 1. What is the ratio of the Area (% of total land area) in Arable land in 2002 to that in 2004?
Offer a very short reply. 1. What is the ratio of the Area (% of total land area) in Permanent crop land in 2002 to that in 2004?
Offer a terse response. 1. What is the ratio of the Area (% of total land area) in Terrestrial protected areas in 2002 to that in 2005?
Offer a terse response. 1. What is the ratio of the Area (% of total land area) in Agricultural land in 2002 to that in 2005?
Provide a succinct answer. 1.03. What is the ratio of the Area (% of total land area) in Arable land in 2002 to that in 2005?
Offer a terse response. 1. What is the ratio of the Area (% of total land area) of Agricultural land in 2002 to that in 2006?
Your answer should be compact. 1.03. What is the ratio of the Area (% of total land area) of Arable land in 2002 to that in 2006?
Provide a short and direct response. 0.99. What is the ratio of the Area (% of total land area) of Terrestrial protected areas in 2003 to that in 2004?
Your answer should be very brief. 1. What is the ratio of the Area (% of total land area) of Arable land in 2003 to that in 2004?
Provide a succinct answer. 1. What is the ratio of the Area (% of total land area) in Permanent crop land in 2003 to that in 2004?
Keep it short and to the point. 1. What is the ratio of the Area (% of total land area) of Agricultural land in 2003 to that in 2005?
Keep it short and to the point. 1.03. What is the ratio of the Area (% of total land area) in Arable land in 2003 to that in 2005?
Offer a very short reply. 1. What is the ratio of the Area (% of total land area) of Permanent crop land in 2003 to that in 2005?
Your response must be concise. 1. What is the ratio of the Area (% of total land area) in Terrestrial protected areas in 2003 to that in 2006?
Offer a very short reply. 1. What is the ratio of the Area (% of total land area) of Agricultural land in 2003 to that in 2006?
Give a very brief answer. 1.03. What is the ratio of the Area (% of total land area) in Arable land in 2003 to that in 2006?
Give a very brief answer. 0.99. What is the ratio of the Area (% of total land area) of Permanent crop land in 2003 to that in 2006?
Provide a succinct answer. 1. What is the ratio of the Area (% of total land area) in Terrestrial protected areas in 2004 to that in 2005?
Your response must be concise. 1. What is the ratio of the Area (% of total land area) of Agricultural land in 2004 to that in 2005?
Ensure brevity in your answer.  1.03. What is the ratio of the Area (% of total land area) of Permanent crop land in 2004 to that in 2005?
Provide a short and direct response. 1. What is the ratio of the Area (% of total land area) in Agricultural land in 2004 to that in 2006?
Your answer should be very brief. 1.02. What is the ratio of the Area (% of total land area) in Arable land in 2005 to that in 2006?
Your answer should be very brief. 0.99. What is the difference between the highest and the second highest Area (% of total land area) in Terrestrial protected areas?
Offer a terse response. 0.6. What is the difference between the highest and the second highest Area (% of total land area) in Agricultural land?
Make the answer very short. 0. What is the difference between the highest and the second highest Area (% of total land area) of Arable land?
Your answer should be compact. 0.01. What is the difference between the highest and the lowest Area (% of total land area) of Terrestrial protected areas?
Give a very brief answer. 0.62. What is the difference between the highest and the lowest Area (% of total land area) in Agricultural land?
Provide a short and direct response. 2.48. What is the difference between the highest and the lowest Area (% of total land area) in Arable land?
Provide a short and direct response. 0.93. What is the difference between the highest and the lowest Area (% of total land area) in Permanent crop land?
Offer a terse response. 0.05. 